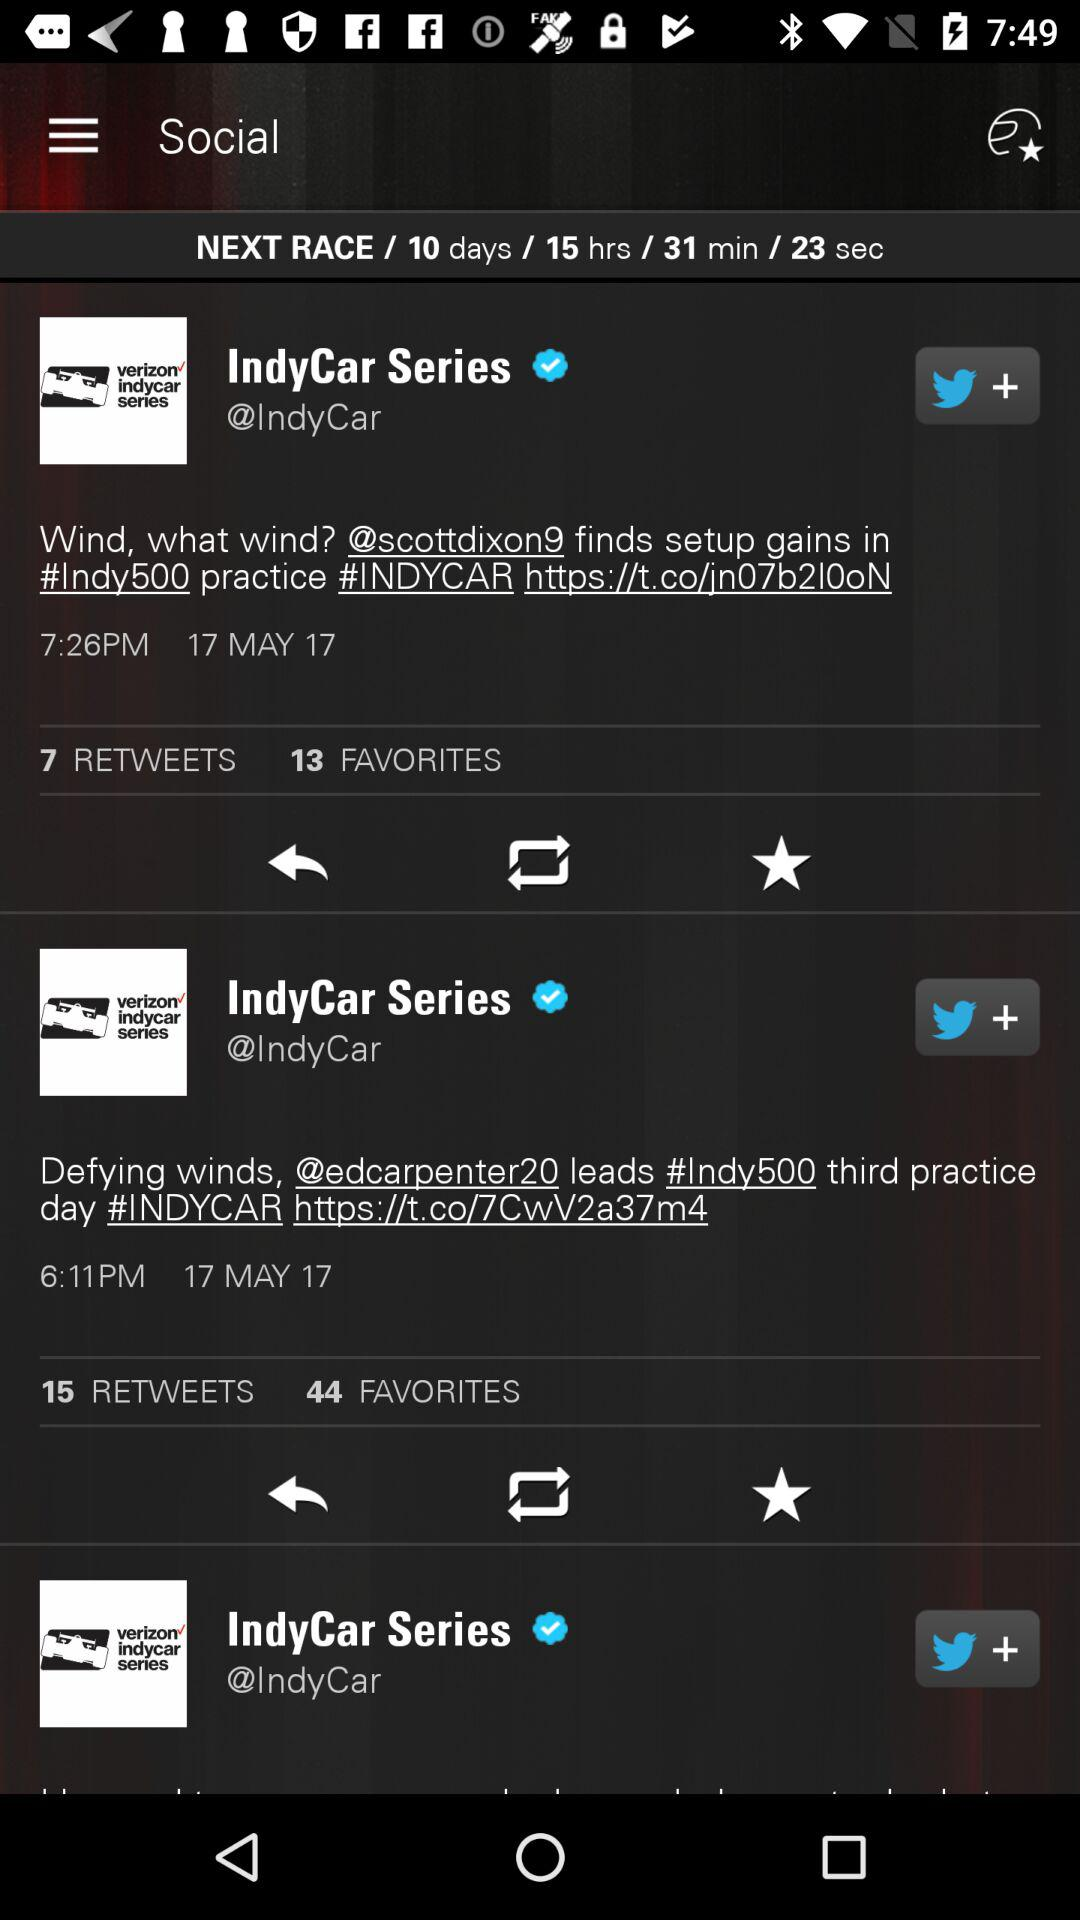How many retweets are there for the tweet by "IndyCar Series" having 13 favorites? There are 7 retweets. 